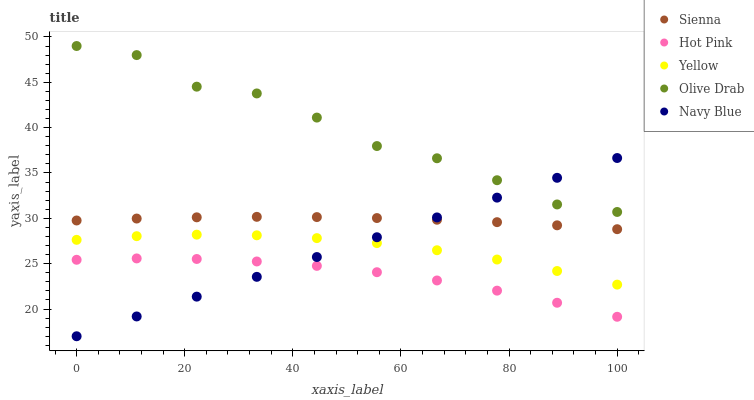Does Hot Pink have the minimum area under the curve?
Answer yes or no. Yes. Does Olive Drab have the maximum area under the curve?
Answer yes or no. Yes. Does Navy Blue have the minimum area under the curve?
Answer yes or no. No. Does Navy Blue have the maximum area under the curve?
Answer yes or no. No. Is Navy Blue the smoothest?
Answer yes or no. Yes. Is Olive Drab the roughest?
Answer yes or no. Yes. Is Hot Pink the smoothest?
Answer yes or no. No. Is Hot Pink the roughest?
Answer yes or no. No. Does Navy Blue have the lowest value?
Answer yes or no. Yes. Does Hot Pink have the lowest value?
Answer yes or no. No. Does Olive Drab have the highest value?
Answer yes or no. Yes. Does Navy Blue have the highest value?
Answer yes or no. No. Is Hot Pink less than Olive Drab?
Answer yes or no. Yes. Is Sienna greater than Hot Pink?
Answer yes or no. Yes. Does Navy Blue intersect Hot Pink?
Answer yes or no. Yes. Is Navy Blue less than Hot Pink?
Answer yes or no. No. Is Navy Blue greater than Hot Pink?
Answer yes or no. No. Does Hot Pink intersect Olive Drab?
Answer yes or no. No. 